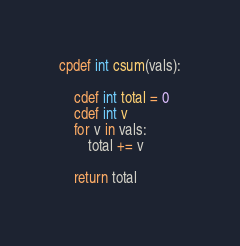<code> <loc_0><loc_0><loc_500><loc_500><_Cython_>cpdef int csum(vals):

    cdef int total = 0
    cdef int v
    for v in vals:
        total += v

    return total</code> 